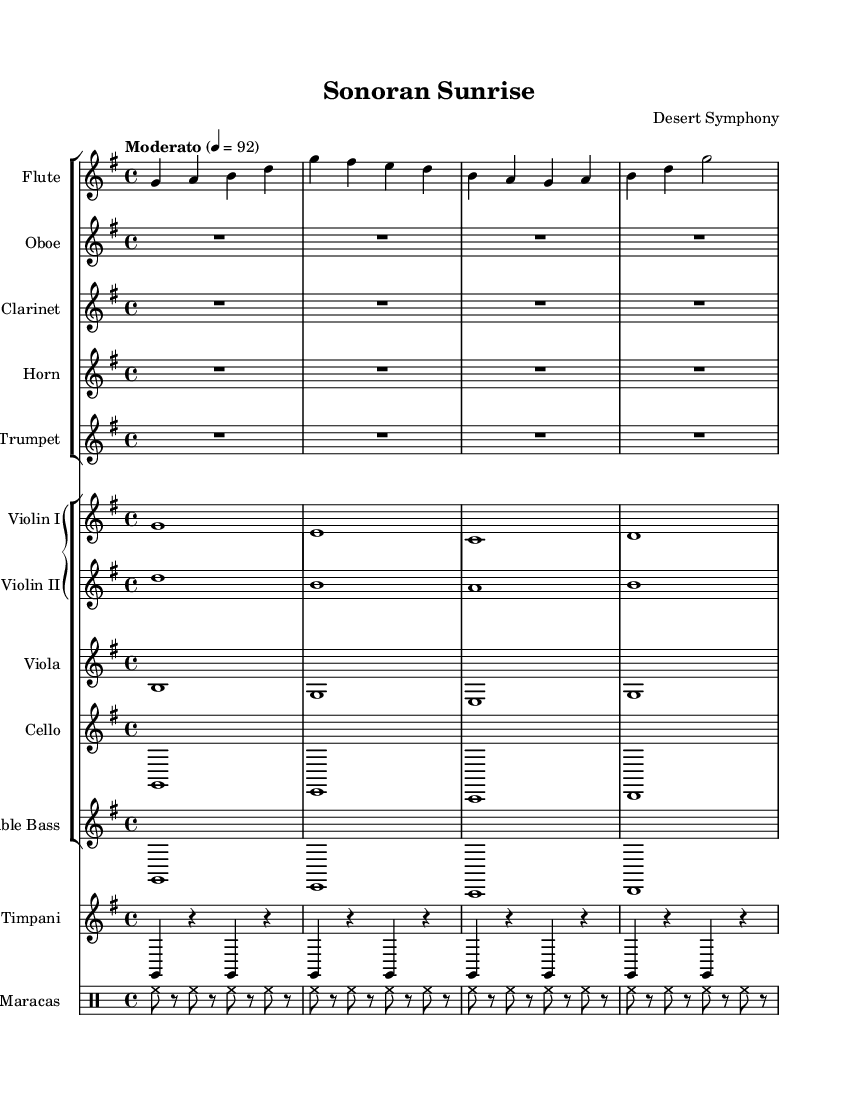What is the key signature of this music? The key signature is G major, which has one sharp (F#).
Answer: G major What is the time signature of this music? The time signature is 4/4, meaning there are four beats in a measure.
Answer: 4/4 What is the tempo marking of the piece? The tempo marking is "Moderato," indicating a moderate speed, set to 92 beats per minute.
Answer: Moderato Which instrument has the longest rest in the first section? The oboe, clarinet, horn, and trumpet all have a whole note rest (R1*4), which is the longest among the instruments.
Answer: Oboe, Clarinet, Horn, Trumpet What type of percussion instrument is used in the score? The score includes Timpani and Maracas, which are percussion instruments that add rhythm and texture.
Answer: Timpani and Maracas What is the structure of the first violin part in terms of note values? The first violin part has whole notes (g1, e, c, d), each representing a measure of whole note duration.
Answer: Whole notes 